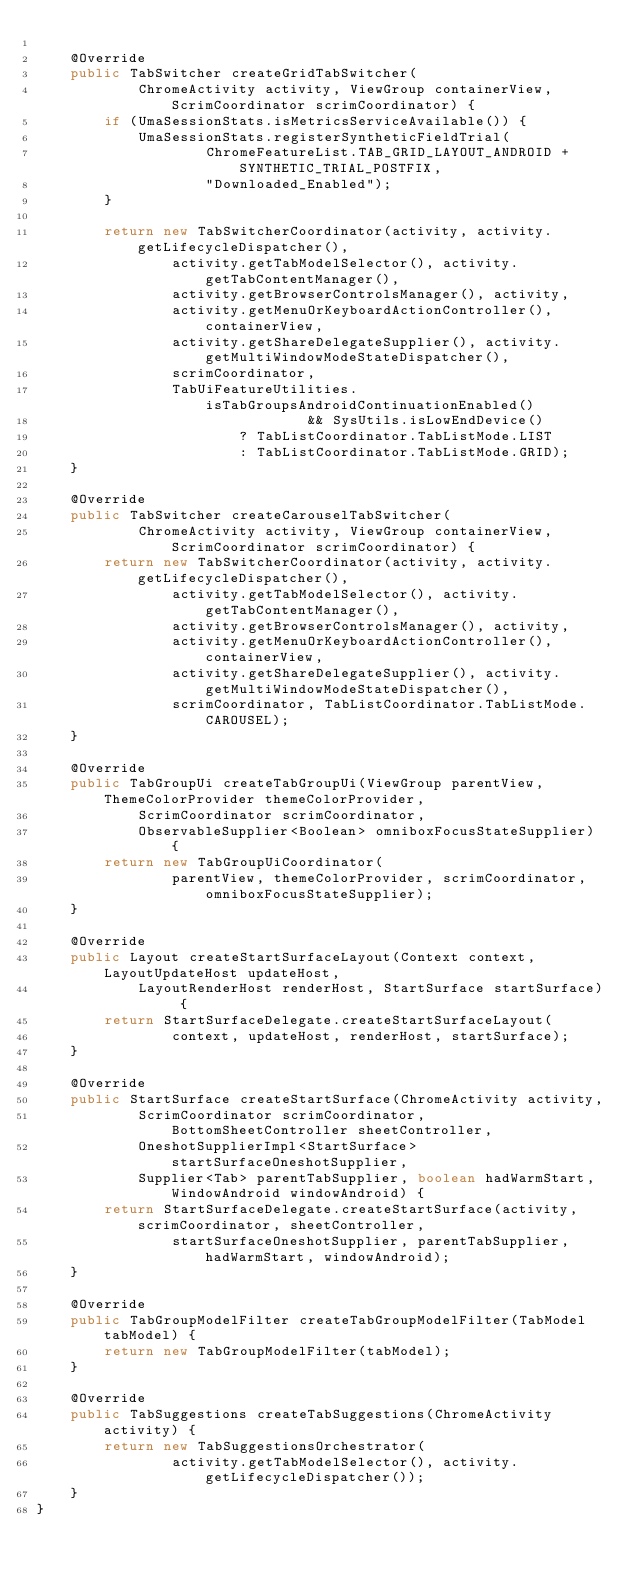Convert code to text. <code><loc_0><loc_0><loc_500><loc_500><_Java_>
    @Override
    public TabSwitcher createGridTabSwitcher(
            ChromeActivity activity, ViewGroup containerView, ScrimCoordinator scrimCoordinator) {
        if (UmaSessionStats.isMetricsServiceAvailable()) {
            UmaSessionStats.registerSyntheticFieldTrial(
                    ChromeFeatureList.TAB_GRID_LAYOUT_ANDROID + SYNTHETIC_TRIAL_POSTFIX,
                    "Downloaded_Enabled");
        }

        return new TabSwitcherCoordinator(activity, activity.getLifecycleDispatcher(),
                activity.getTabModelSelector(), activity.getTabContentManager(),
                activity.getBrowserControlsManager(), activity,
                activity.getMenuOrKeyboardActionController(), containerView,
                activity.getShareDelegateSupplier(), activity.getMultiWindowModeStateDispatcher(),
                scrimCoordinator,
                TabUiFeatureUtilities.isTabGroupsAndroidContinuationEnabled()
                                && SysUtils.isLowEndDevice()
                        ? TabListCoordinator.TabListMode.LIST
                        : TabListCoordinator.TabListMode.GRID);
    }

    @Override
    public TabSwitcher createCarouselTabSwitcher(
            ChromeActivity activity, ViewGroup containerView, ScrimCoordinator scrimCoordinator) {
        return new TabSwitcherCoordinator(activity, activity.getLifecycleDispatcher(),
                activity.getTabModelSelector(), activity.getTabContentManager(),
                activity.getBrowserControlsManager(), activity,
                activity.getMenuOrKeyboardActionController(), containerView,
                activity.getShareDelegateSupplier(), activity.getMultiWindowModeStateDispatcher(),
                scrimCoordinator, TabListCoordinator.TabListMode.CAROUSEL);
    }

    @Override
    public TabGroupUi createTabGroupUi(ViewGroup parentView, ThemeColorProvider themeColorProvider,
            ScrimCoordinator scrimCoordinator,
            ObservableSupplier<Boolean> omniboxFocusStateSupplier) {
        return new TabGroupUiCoordinator(
                parentView, themeColorProvider, scrimCoordinator, omniboxFocusStateSupplier);
    }

    @Override
    public Layout createStartSurfaceLayout(Context context, LayoutUpdateHost updateHost,
            LayoutRenderHost renderHost, StartSurface startSurface) {
        return StartSurfaceDelegate.createStartSurfaceLayout(
                context, updateHost, renderHost, startSurface);
    }

    @Override
    public StartSurface createStartSurface(ChromeActivity activity,
            ScrimCoordinator scrimCoordinator, BottomSheetController sheetController,
            OneshotSupplierImpl<StartSurface> startSurfaceOneshotSupplier,
            Supplier<Tab> parentTabSupplier, boolean hadWarmStart, WindowAndroid windowAndroid) {
        return StartSurfaceDelegate.createStartSurface(activity, scrimCoordinator, sheetController,
                startSurfaceOneshotSupplier, parentTabSupplier, hadWarmStart, windowAndroid);
    }

    @Override
    public TabGroupModelFilter createTabGroupModelFilter(TabModel tabModel) {
        return new TabGroupModelFilter(tabModel);
    }

    @Override
    public TabSuggestions createTabSuggestions(ChromeActivity activity) {
        return new TabSuggestionsOrchestrator(
                activity.getTabModelSelector(), activity.getLifecycleDispatcher());
    }
}
</code> 